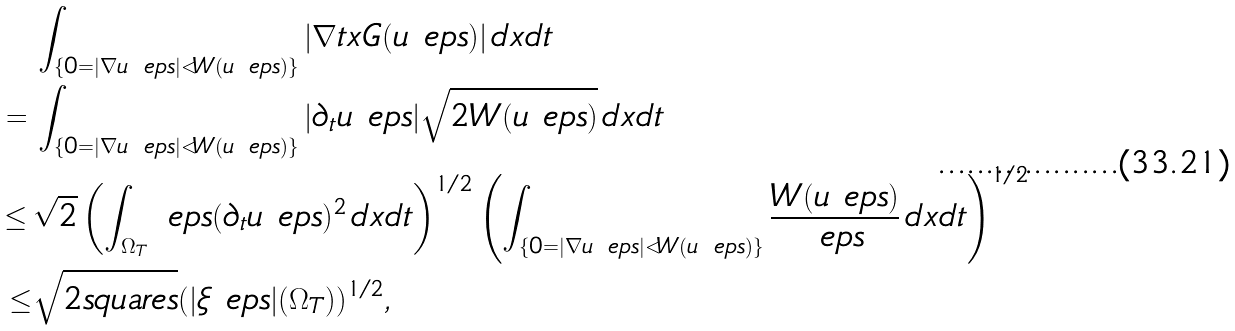<formula> <loc_0><loc_0><loc_500><loc_500>& \int _ { \{ 0 = | \nabla u _ { \ } e p s | < W ( u _ { \ } e p s ) \} } | \nabla t x G ( u _ { \ } e p s ) | \, d x d t \\ = \, & \int _ { \{ 0 = | \nabla u _ { \ } e p s | < W ( u _ { \ } e p s ) \} } | \partial _ { t } u _ { \ } e p s | \sqrt { 2 W ( u _ { \ } e p s ) } \, d x d t \\ \leq \, & \sqrt { 2 } \left ( \int _ { \Omega _ { T } } \ e p s ( \partial _ { t } u _ { \ } e p s ) ^ { 2 } \, d x d t \right ) ^ { 1 / 2 } \left ( \int _ { \{ 0 = | \nabla u _ { \ } e p s | < W ( u _ { \ } e p s ) \} } \frac { W ( u _ { \ } e p s ) } { \ e p s } \, d x d t \right ) ^ { 1 / 2 } \\ \leq & \sqrt { 2 \L s q u a r e s } ( | \xi _ { \ } e p s | ( \Omega _ { T } ) ) ^ { 1 / 2 } ,</formula> 